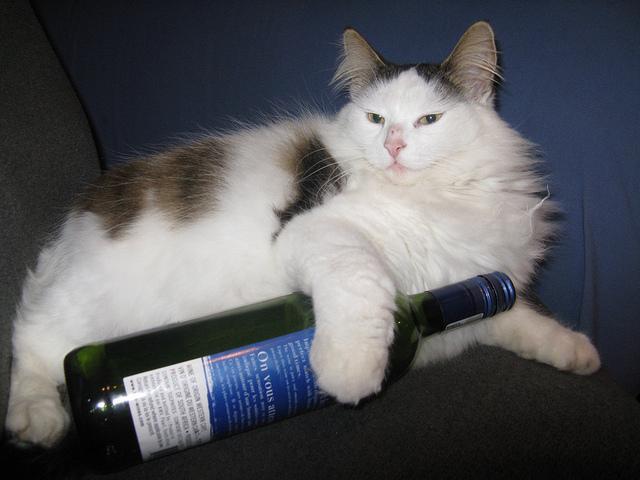How many people are wearing a white hat in a frame?
Give a very brief answer. 0. 